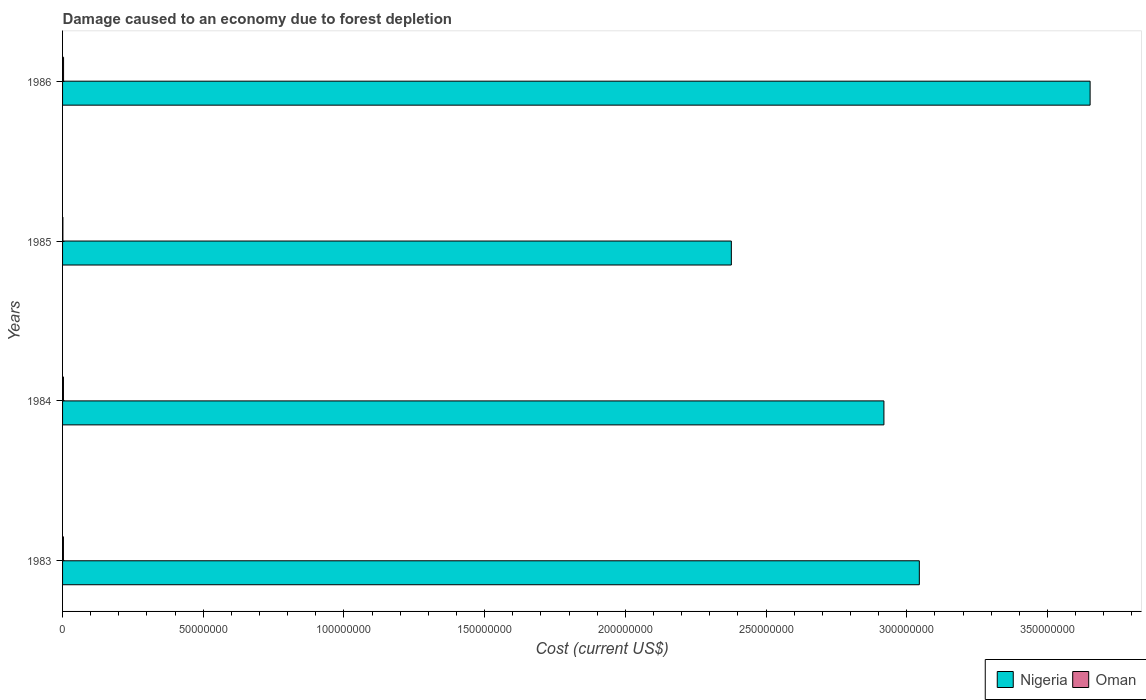How many different coloured bars are there?
Provide a succinct answer. 2. How many groups of bars are there?
Give a very brief answer. 4. Are the number of bars on each tick of the Y-axis equal?
Provide a short and direct response. Yes. How many bars are there on the 2nd tick from the top?
Offer a very short reply. 2. What is the cost of damage caused due to forest depletion in Nigeria in 1986?
Keep it short and to the point. 3.65e+08. Across all years, what is the maximum cost of damage caused due to forest depletion in Nigeria?
Ensure brevity in your answer.  3.65e+08. Across all years, what is the minimum cost of damage caused due to forest depletion in Nigeria?
Make the answer very short. 2.38e+08. What is the total cost of damage caused due to forest depletion in Oman in the graph?
Give a very brief answer. 1.09e+06. What is the difference between the cost of damage caused due to forest depletion in Nigeria in 1984 and that in 1985?
Offer a very short reply. 5.42e+07. What is the difference between the cost of damage caused due to forest depletion in Oman in 1985 and the cost of damage caused due to forest depletion in Nigeria in 1983?
Provide a short and direct response. -3.04e+08. What is the average cost of damage caused due to forest depletion in Nigeria per year?
Make the answer very short. 3.00e+08. In the year 1985, what is the difference between the cost of damage caused due to forest depletion in Oman and cost of damage caused due to forest depletion in Nigeria?
Your answer should be very brief. -2.38e+08. What is the ratio of the cost of damage caused due to forest depletion in Oman in 1985 to that in 1986?
Ensure brevity in your answer.  0.33. Is the cost of damage caused due to forest depletion in Oman in 1983 less than that in 1984?
Make the answer very short. Yes. Is the difference between the cost of damage caused due to forest depletion in Oman in 1984 and 1986 greater than the difference between the cost of damage caused due to forest depletion in Nigeria in 1984 and 1986?
Give a very brief answer. Yes. What is the difference between the highest and the second highest cost of damage caused due to forest depletion in Nigeria?
Provide a short and direct response. 6.07e+07. What is the difference between the highest and the lowest cost of damage caused due to forest depletion in Oman?
Give a very brief answer. 2.37e+05. What does the 1st bar from the top in 1985 represents?
Provide a short and direct response. Oman. What does the 2nd bar from the bottom in 1986 represents?
Give a very brief answer. Oman. What is the difference between two consecutive major ticks on the X-axis?
Your response must be concise. 5.00e+07. Are the values on the major ticks of X-axis written in scientific E-notation?
Offer a very short reply. No. How many legend labels are there?
Offer a very short reply. 2. How are the legend labels stacked?
Your answer should be compact. Horizontal. What is the title of the graph?
Give a very brief answer. Damage caused to an economy due to forest depletion. Does "Swaziland" appear as one of the legend labels in the graph?
Offer a terse response. No. What is the label or title of the X-axis?
Make the answer very short. Cost (current US$). What is the Cost (current US$) of Nigeria in 1983?
Provide a short and direct response. 3.04e+08. What is the Cost (current US$) in Oman in 1983?
Provide a short and direct response. 3.07e+05. What is the Cost (current US$) of Nigeria in 1984?
Make the answer very short. 2.92e+08. What is the Cost (current US$) of Oman in 1984?
Offer a terse response. 3.16e+05. What is the Cost (current US$) in Nigeria in 1985?
Your response must be concise. 2.38e+08. What is the Cost (current US$) in Oman in 1985?
Provide a short and direct response. 1.15e+05. What is the Cost (current US$) of Nigeria in 1986?
Provide a succinct answer. 3.65e+08. What is the Cost (current US$) in Oman in 1986?
Your response must be concise. 3.53e+05. Across all years, what is the maximum Cost (current US$) in Nigeria?
Provide a succinct answer. 3.65e+08. Across all years, what is the maximum Cost (current US$) in Oman?
Ensure brevity in your answer.  3.53e+05. Across all years, what is the minimum Cost (current US$) of Nigeria?
Your answer should be compact. 2.38e+08. Across all years, what is the minimum Cost (current US$) in Oman?
Your answer should be compact. 1.15e+05. What is the total Cost (current US$) in Nigeria in the graph?
Provide a succinct answer. 1.20e+09. What is the total Cost (current US$) in Oman in the graph?
Your response must be concise. 1.09e+06. What is the difference between the Cost (current US$) of Nigeria in 1983 and that in 1984?
Offer a terse response. 1.26e+07. What is the difference between the Cost (current US$) of Oman in 1983 and that in 1984?
Provide a succinct answer. -8714.88. What is the difference between the Cost (current US$) in Nigeria in 1983 and that in 1985?
Keep it short and to the point. 6.68e+07. What is the difference between the Cost (current US$) of Oman in 1983 and that in 1985?
Your response must be concise. 1.92e+05. What is the difference between the Cost (current US$) in Nigeria in 1983 and that in 1986?
Offer a terse response. -6.07e+07. What is the difference between the Cost (current US$) of Oman in 1983 and that in 1986?
Ensure brevity in your answer.  -4.56e+04. What is the difference between the Cost (current US$) of Nigeria in 1984 and that in 1985?
Provide a succinct answer. 5.42e+07. What is the difference between the Cost (current US$) in Oman in 1984 and that in 1985?
Your answer should be very brief. 2.01e+05. What is the difference between the Cost (current US$) in Nigeria in 1984 and that in 1986?
Make the answer very short. -7.33e+07. What is the difference between the Cost (current US$) in Oman in 1984 and that in 1986?
Give a very brief answer. -3.69e+04. What is the difference between the Cost (current US$) in Nigeria in 1985 and that in 1986?
Offer a terse response. -1.27e+08. What is the difference between the Cost (current US$) of Oman in 1985 and that in 1986?
Provide a short and direct response. -2.37e+05. What is the difference between the Cost (current US$) of Nigeria in 1983 and the Cost (current US$) of Oman in 1984?
Ensure brevity in your answer.  3.04e+08. What is the difference between the Cost (current US$) of Nigeria in 1983 and the Cost (current US$) of Oman in 1985?
Keep it short and to the point. 3.04e+08. What is the difference between the Cost (current US$) of Nigeria in 1983 and the Cost (current US$) of Oman in 1986?
Give a very brief answer. 3.04e+08. What is the difference between the Cost (current US$) in Nigeria in 1984 and the Cost (current US$) in Oman in 1985?
Offer a terse response. 2.92e+08. What is the difference between the Cost (current US$) of Nigeria in 1984 and the Cost (current US$) of Oman in 1986?
Provide a short and direct response. 2.92e+08. What is the difference between the Cost (current US$) in Nigeria in 1985 and the Cost (current US$) in Oman in 1986?
Your answer should be very brief. 2.37e+08. What is the average Cost (current US$) of Nigeria per year?
Your answer should be very brief. 3.00e+08. What is the average Cost (current US$) of Oman per year?
Make the answer very short. 2.73e+05. In the year 1983, what is the difference between the Cost (current US$) of Nigeria and Cost (current US$) of Oman?
Provide a succinct answer. 3.04e+08. In the year 1984, what is the difference between the Cost (current US$) of Nigeria and Cost (current US$) of Oman?
Offer a very short reply. 2.92e+08. In the year 1985, what is the difference between the Cost (current US$) of Nigeria and Cost (current US$) of Oman?
Make the answer very short. 2.38e+08. In the year 1986, what is the difference between the Cost (current US$) of Nigeria and Cost (current US$) of Oman?
Provide a succinct answer. 3.65e+08. What is the ratio of the Cost (current US$) of Nigeria in 1983 to that in 1984?
Provide a short and direct response. 1.04. What is the ratio of the Cost (current US$) in Oman in 1983 to that in 1984?
Provide a short and direct response. 0.97. What is the ratio of the Cost (current US$) of Nigeria in 1983 to that in 1985?
Offer a very short reply. 1.28. What is the ratio of the Cost (current US$) in Oman in 1983 to that in 1985?
Give a very brief answer. 2.67. What is the ratio of the Cost (current US$) in Nigeria in 1983 to that in 1986?
Make the answer very short. 0.83. What is the ratio of the Cost (current US$) in Oman in 1983 to that in 1986?
Your answer should be very brief. 0.87. What is the ratio of the Cost (current US$) in Nigeria in 1984 to that in 1985?
Offer a very short reply. 1.23. What is the ratio of the Cost (current US$) in Oman in 1984 to that in 1985?
Keep it short and to the point. 2.74. What is the ratio of the Cost (current US$) in Nigeria in 1984 to that in 1986?
Your response must be concise. 0.8. What is the ratio of the Cost (current US$) of Oman in 1984 to that in 1986?
Your answer should be very brief. 0.9. What is the ratio of the Cost (current US$) of Nigeria in 1985 to that in 1986?
Offer a terse response. 0.65. What is the ratio of the Cost (current US$) in Oman in 1985 to that in 1986?
Your response must be concise. 0.33. What is the difference between the highest and the second highest Cost (current US$) in Nigeria?
Give a very brief answer. 6.07e+07. What is the difference between the highest and the second highest Cost (current US$) of Oman?
Your answer should be very brief. 3.69e+04. What is the difference between the highest and the lowest Cost (current US$) of Nigeria?
Provide a short and direct response. 1.27e+08. What is the difference between the highest and the lowest Cost (current US$) in Oman?
Provide a short and direct response. 2.37e+05. 